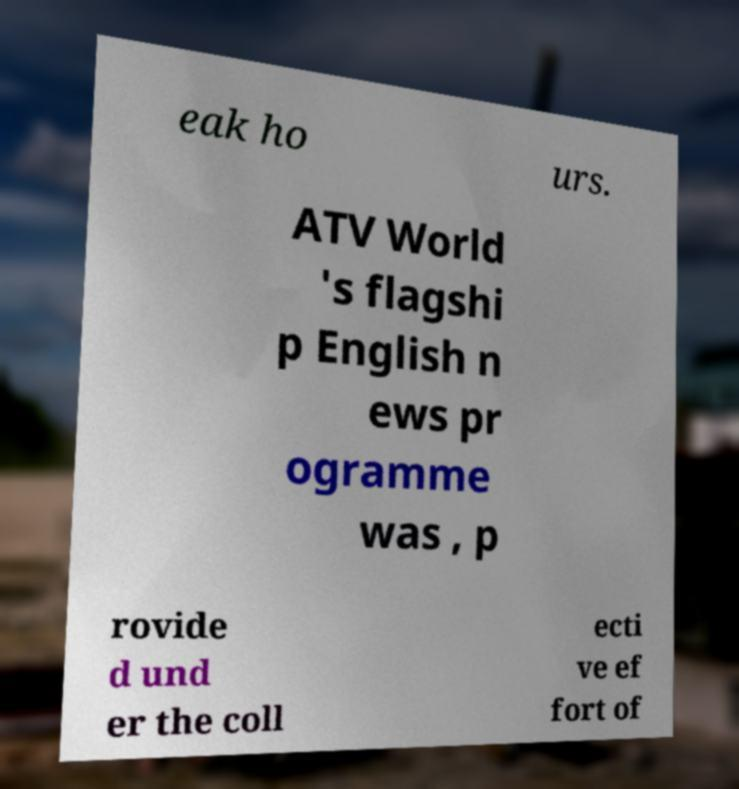Could you assist in decoding the text presented in this image and type it out clearly? eak ho urs. ATV World 's flagshi p English n ews pr ogramme was , p rovide d und er the coll ecti ve ef fort of 